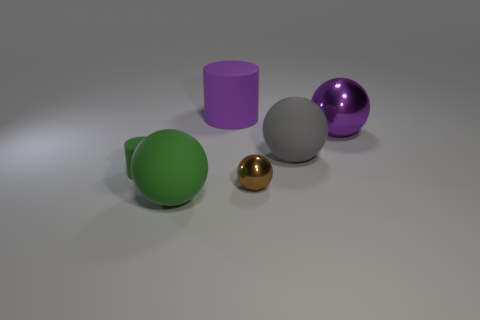Add 3 large purple shiny spheres. How many objects exist? 9 Subtract all cylinders. How many objects are left? 4 Subtract all red metal balls. Subtract all shiny things. How many objects are left? 4 Add 1 tiny green cylinders. How many tiny green cylinders are left? 2 Add 2 purple cylinders. How many purple cylinders exist? 3 Subtract 0 yellow spheres. How many objects are left? 6 